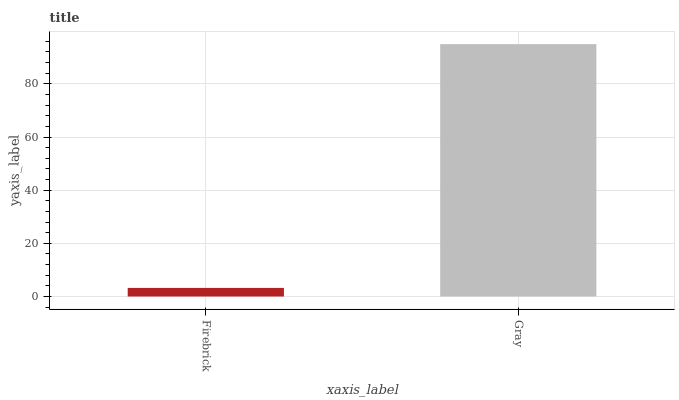Is Gray the minimum?
Answer yes or no. No. Is Gray greater than Firebrick?
Answer yes or no. Yes. Is Firebrick less than Gray?
Answer yes or no. Yes. Is Firebrick greater than Gray?
Answer yes or no. No. Is Gray less than Firebrick?
Answer yes or no. No. Is Gray the high median?
Answer yes or no. Yes. Is Firebrick the low median?
Answer yes or no. Yes. Is Firebrick the high median?
Answer yes or no. No. Is Gray the low median?
Answer yes or no. No. 